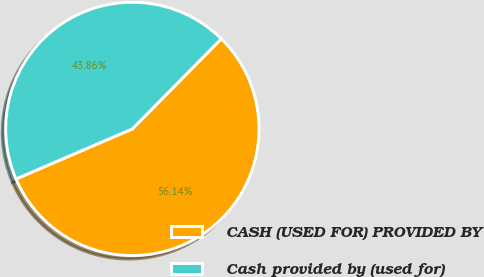Convert chart to OTSL. <chart><loc_0><loc_0><loc_500><loc_500><pie_chart><fcel>CASH (USED FOR) PROVIDED BY<fcel>Cash provided by (used for)<nl><fcel>56.14%<fcel>43.86%<nl></chart> 